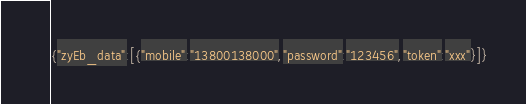<code> <loc_0><loc_0><loc_500><loc_500><_JavaScript_>{"zyEb_data":[{"mobile":"13800138000","password":"123456","token":"xxx"}]}</code> 